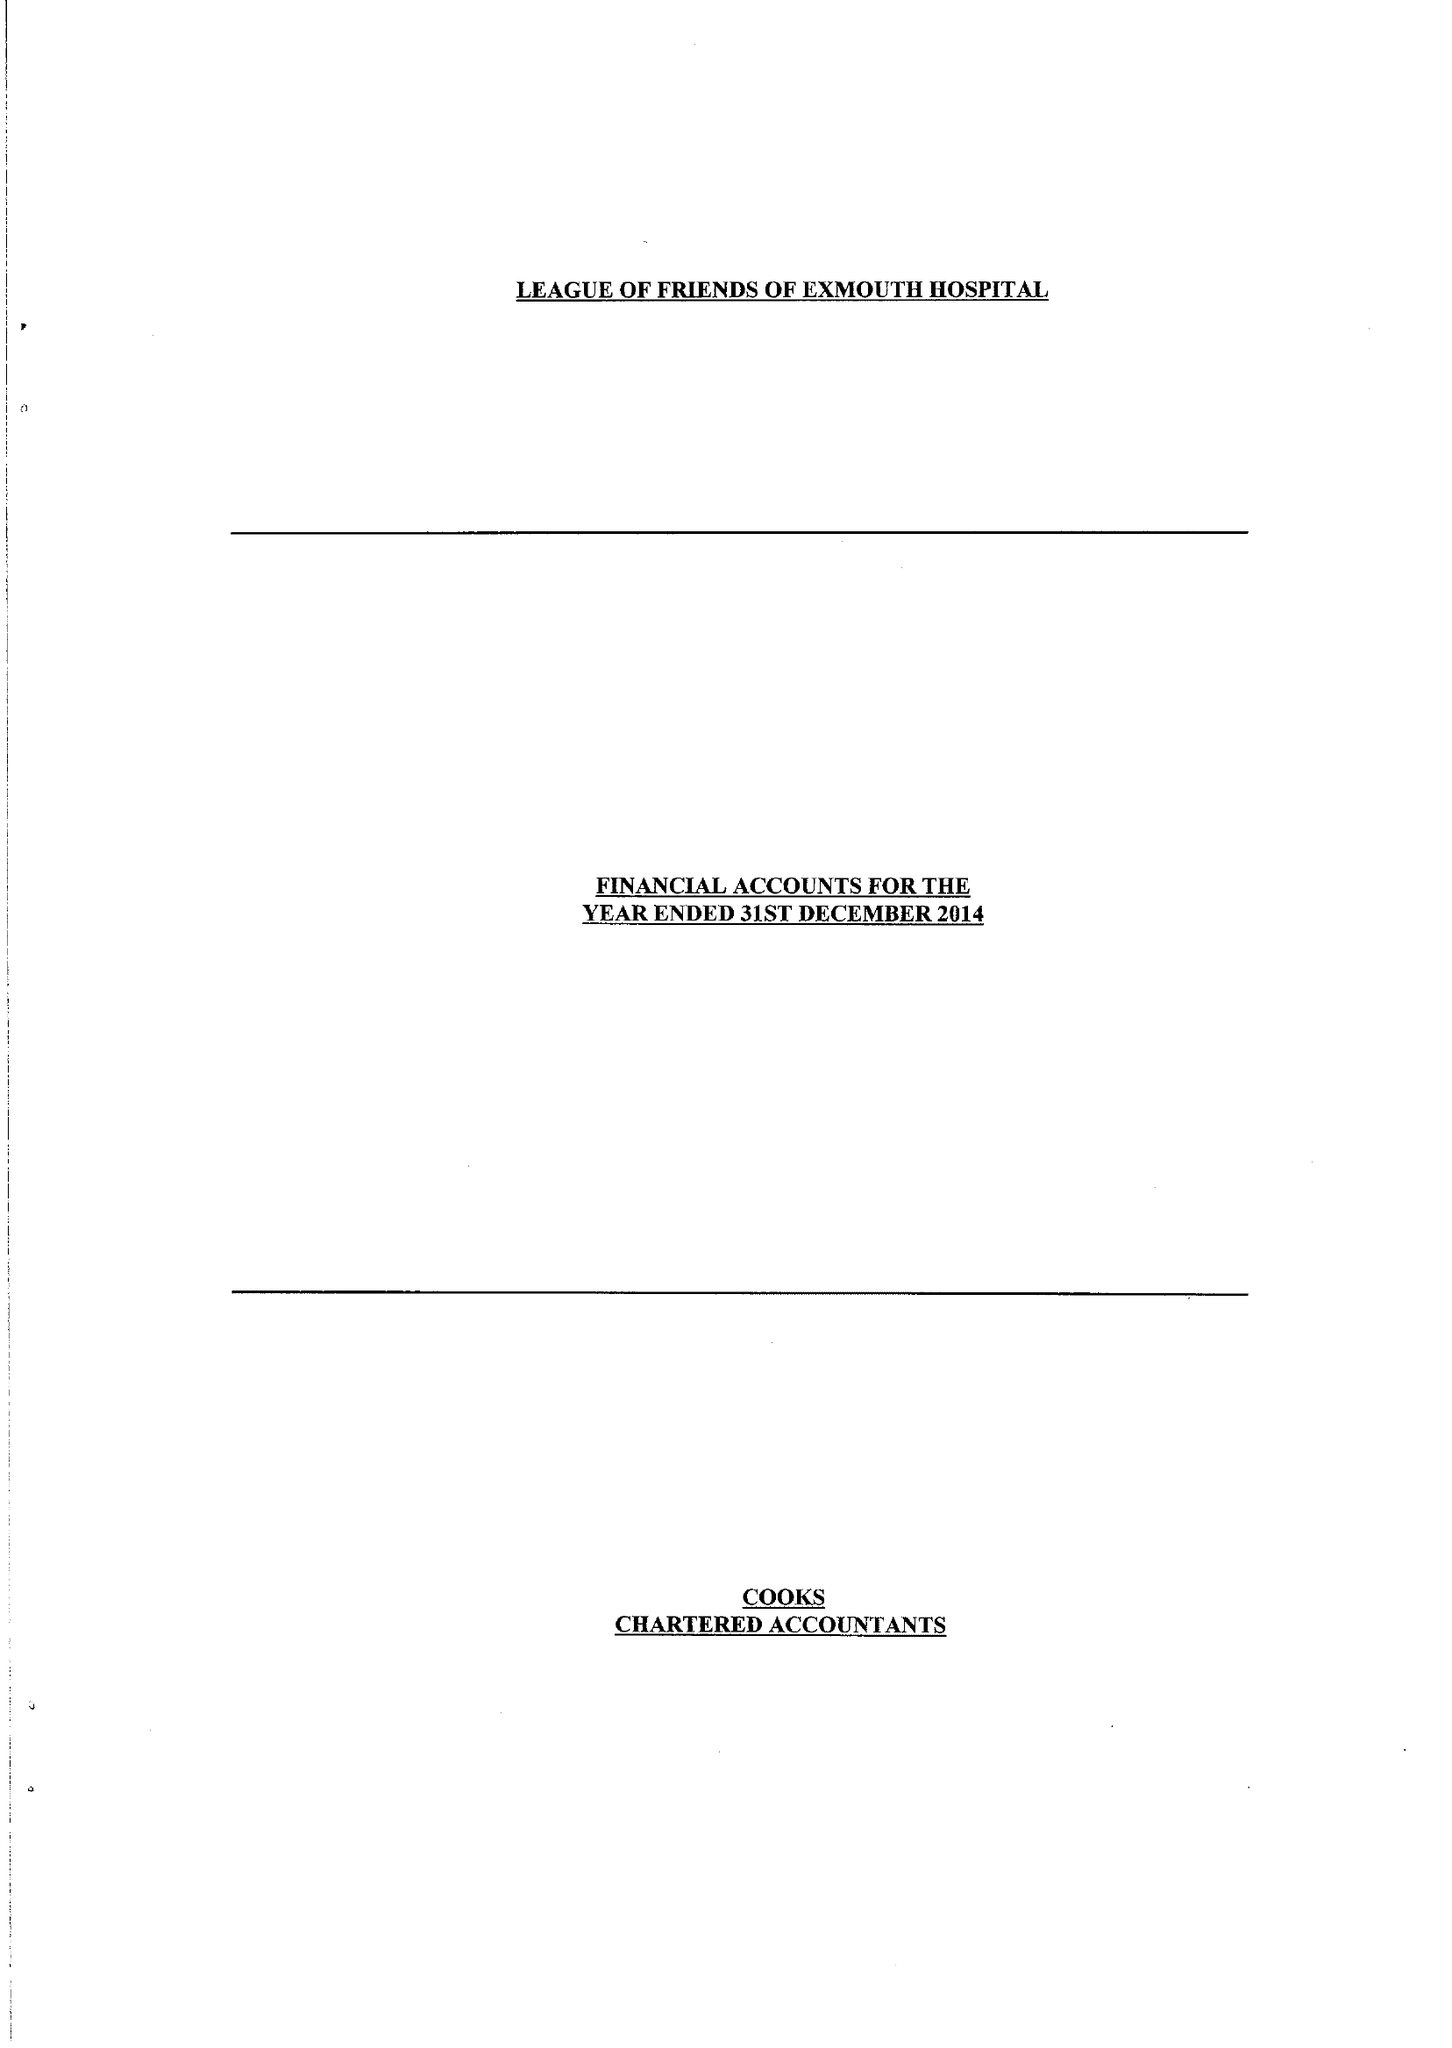What is the value for the report_date?
Answer the question using a single word or phrase. 2014-12-31 